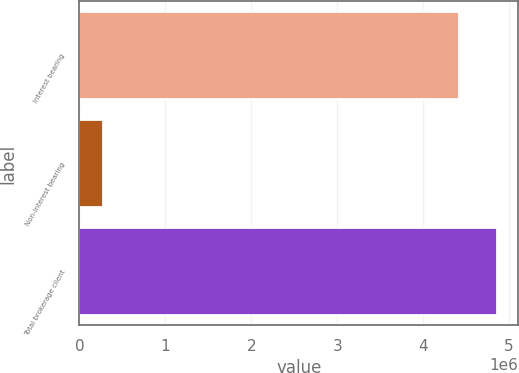Convert chart. <chart><loc_0><loc_0><loc_500><loc_500><bar_chart><fcel>Interest bearing<fcel>Non-interest bearing<fcel>Total brokerage client<nl><fcel>4.42028e+06<fcel>270131<fcel>4.86231e+06<nl></chart> 